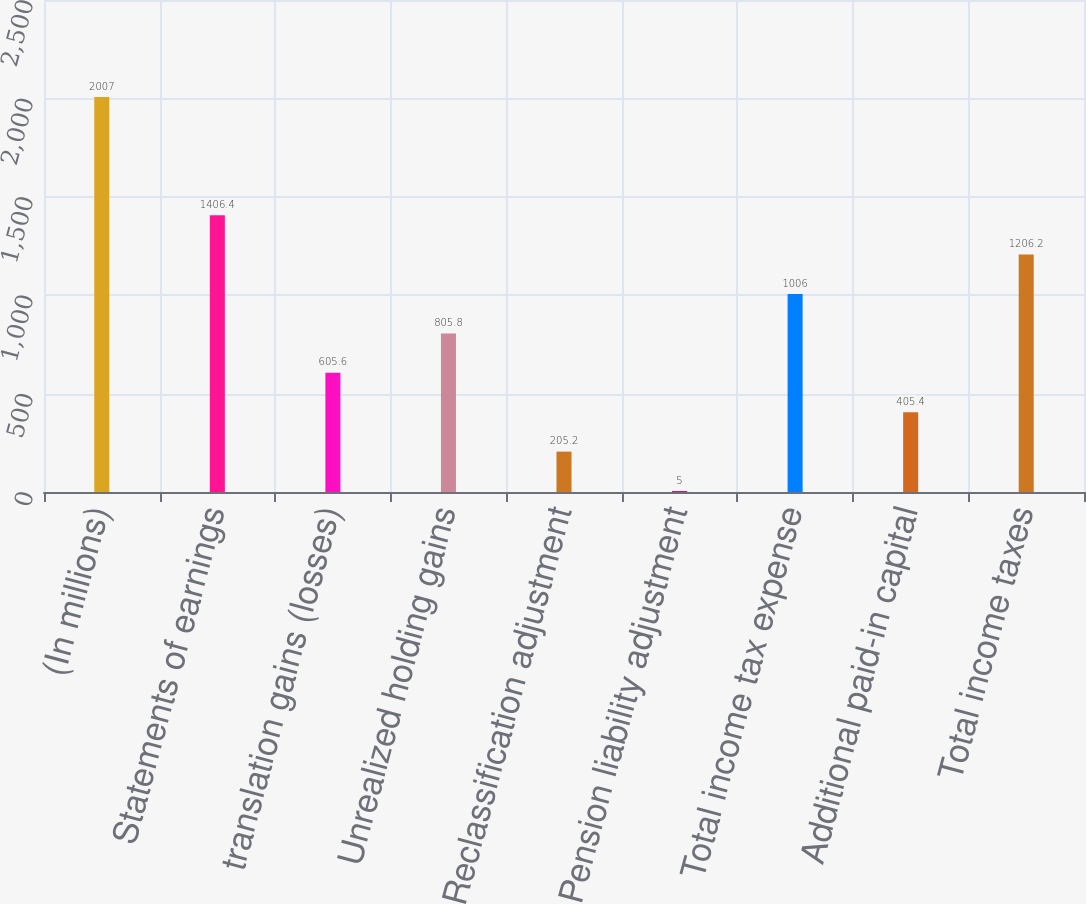<chart> <loc_0><loc_0><loc_500><loc_500><bar_chart><fcel>(In millions)<fcel>Statements of earnings<fcel>translation gains (losses)<fcel>Unrealized holding gains<fcel>Reclassification adjustment<fcel>Pension liability adjustment<fcel>Total income tax expense<fcel>Additional paid-in capital<fcel>Total income taxes<nl><fcel>2007<fcel>1406.4<fcel>605.6<fcel>805.8<fcel>205.2<fcel>5<fcel>1006<fcel>405.4<fcel>1206.2<nl></chart> 